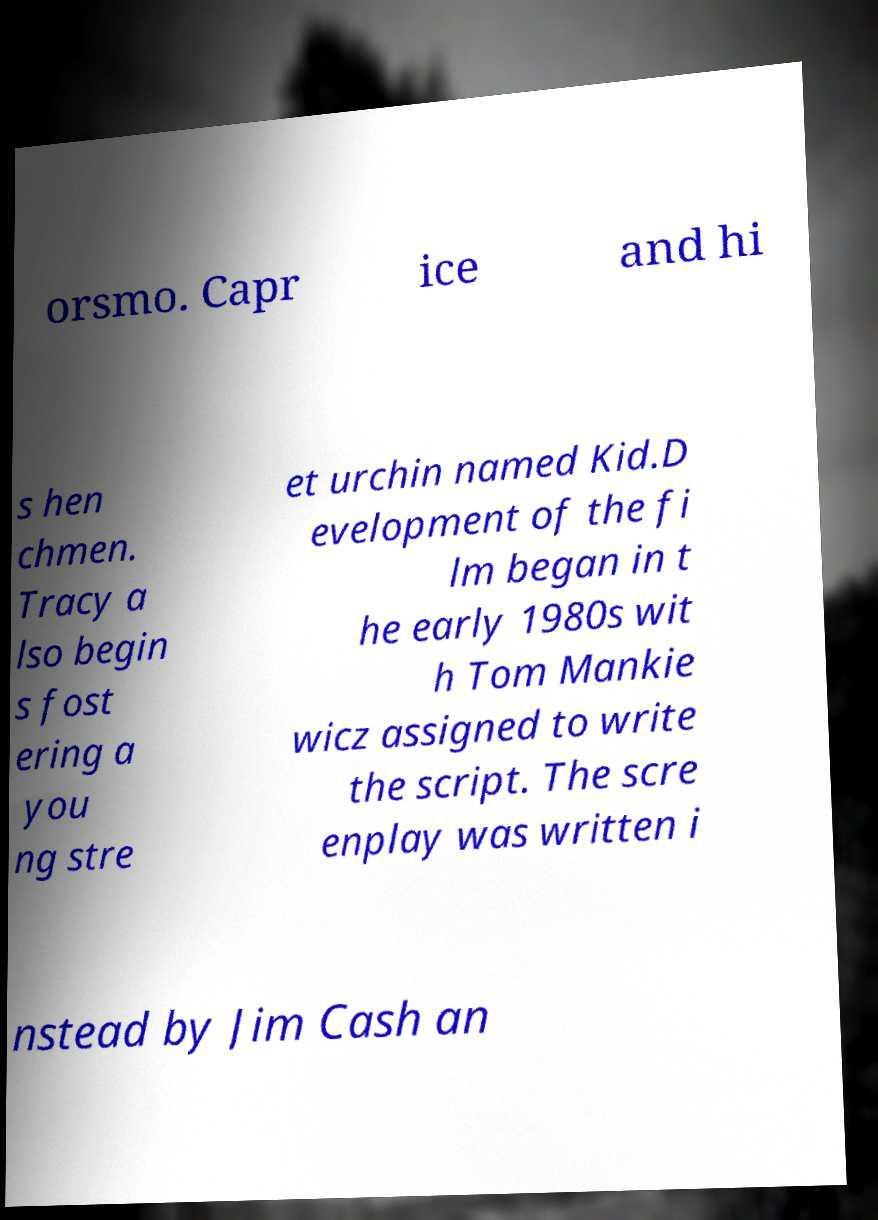Can you read and provide the text displayed in the image?This photo seems to have some interesting text. Can you extract and type it out for me? orsmo. Capr ice and hi s hen chmen. Tracy a lso begin s fost ering a you ng stre et urchin named Kid.D evelopment of the fi lm began in t he early 1980s wit h Tom Mankie wicz assigned to write the script. The scre enplay was written i nstead by Jim Cash an 